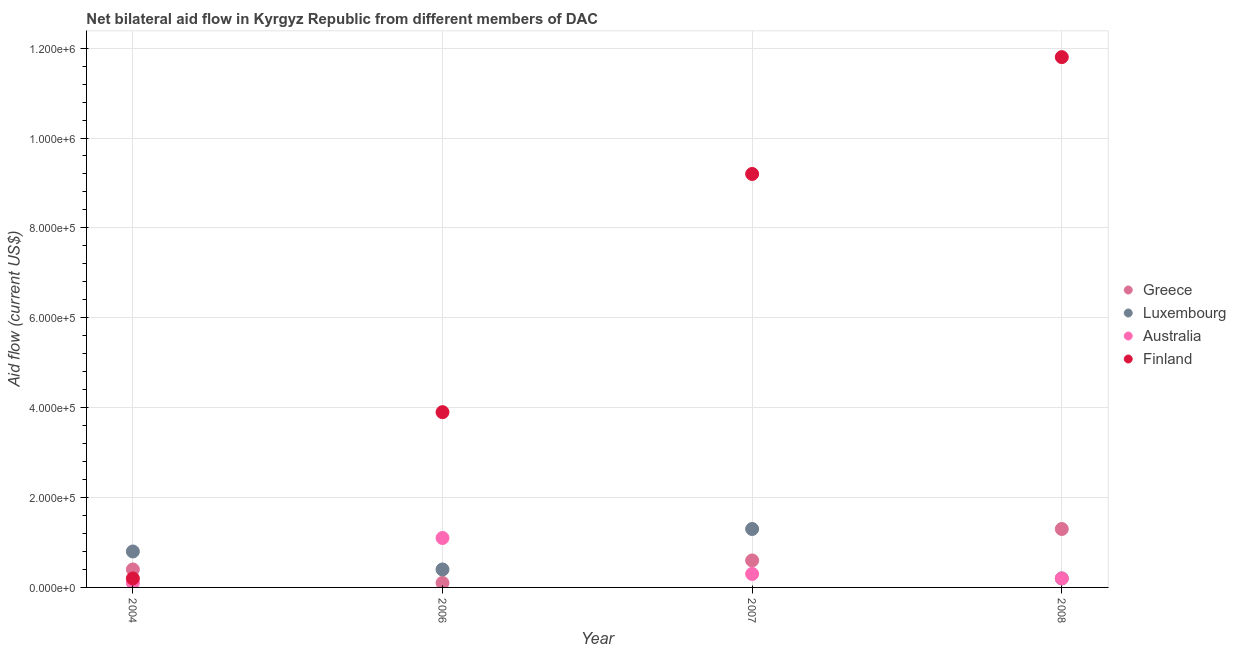What is the amount of aid given by finland in 2007?
Offer a very short reply. 9.20e+05. Across all years, what is the maximum amount of aid given by australia?
Provide a short and direct response. 1.10e+05. Across all years, what is the minimum amount of aid given by greece?
Your response must be concise. 10000. What is the total amount of aid given by greece in the graph?
Provide a short and direct response. 2.40e+05. What is the difference between the amount of aid given by luxembourg in 2004 and that in 2008?
Offer a very short reply. 6.00e+04. What is the difference between the amount of aid given by greece in 2007 and the amount of aid given by australia in 2006?
Your answer should be compact. -5.00e+04. In the year 2007, what is the difference between the amount of aid given by australia and amount of aid given by greece?
Offer a very short reply. -3.00e+04. What is the ratio of the amount of aid given by greece in 2006 to that in 2008?
Offer a very short reply. 0.08. Is the amount of aid given by australia in 2004 less than that in 2006?
Offer a terse response. Yes. Is the difference between the amount of aid given by australia in 2006 and 2007 greater than the difference between the amount of aid given by greece in 2006 and 2007?
Your answer should be compact. Yes. What is the difference between the highest and the second highest amount of aid given by luxembourg?
Keep it short and to the point. 5.00e+04. What is the difference between the highest and the lowest amount of aid given by luxembourg?
Provide a succinct answer. 1.10e+05. Is the sum of the amount of aid given by australia in 2004 and 2007 greater than the maximum amount of aid given by finland across all years?
Provide a succinct answer. No. Is the amount of aid given by australia strictly greater than the amount of aid given by greece over the years?
Provide a short and direct response. No. Is the amount of aid given by greece strictly less than the amount of aid given by finland over the years?
Offer a very short reply. No. Are the values on the major ticks of Y-axis written in scientific E-notation?
Provide a succinct answer. Yes. Where does the legend appear in the graph?
Provide a succinct answer. Center right. What is the title of the graph?
Ensure brevity in your answer.  Net bilateral aid flow in Kyrgyz Republic from different members of DAC. Does "Quality of logistic services" appear as one of the legend labels in the graph?
Offer a terse response. No. What is the label or title of the Y-axis?
Your answer should be compact. Aid flow (current US$). What is the Aid flow (current US$) of Greece in 2004?
Ensure brevity in your answer.  4.00e+04. What is the Aid flow (current US$) of Australia in 2006?
Make the answer very short. 1.10e+05. What is the Aid flow (current US$) in Luxembourg in 2007?
Your answer should be compact. 1.30e+05. What is the Aid flow (current US$) of Finland in 2007?
Provide a succinct answer. 9.20e+05. What is the Aid flow (current US$) in Australia in 2008?
Ensure brevity in your answer.  2.00e+04. What is the Aid flow (current US$) of Finland in 2008?
Ensure brevity in your answer.  1.18e+06. Across all years, what is the maximum Aid flow (current US$) in Luxembourg?
Make the answer very short. 1.30e+05. Across all years, what is the maximum Aid flow (current US$) of Australia?
Make the answer very short. 1.10e+05. Across all years, what is the maximum Aid flow (current US$) in Finland?
Give a very brief answer. 1.18e+06. Across all years, what is the minimum Aid flow (current US$) in Luxembourg?
Give a very brief answer. 2.00e+04. Across all years, what is the minimum Aid flow (current US$) in Australia?
Your response must be concise. 10000. What is the total Aid flow (current US$) in Greece in the graph?
Your answer should be compact. 2.40e+05. What is the total Aid flow (current US$) of Australia in the graph?
Offer a very short reply. 1.70e+05. What is the total Aid flow (current US$) in Finland in the graph?
Your answer should be compact. 2.51e+06. What is the difference between the Aid flow (current US$) of Australia in 2004 and that in 2006?
Your response must be concise. -1.00e+05. What is the difference between the Aid flow (current US$) of Finland in 2004 and that in 2006?
Provide a short and direct response. -3.70e+05. What is the difference between the Aid flow (current US$) in Luxembourg in 2004 and that in 2007?
Your answer should be very brief. -5.00e+04. What is the difference between the Aid flow (current US$) of Finland in 2004 and that in 2007?
Keep it short and to the point. -9.00e+05. What is the difference between the Aid flow (current US$) of Luxembourg in 2004 and that in 2008?
Provide a short and direct response. 6.00e+04. What is the difference between the Aid flow (current US$) of Finland in 2004 and that in 2008?
Ensure brevity in your answer.  -1.16e+06. What is the difference between the Aid flow (current US$) in Luxembourg in 2006 and that in 2007?
Your response must be concise. -9.00e+04. What is the difference between the Aid flow (current US$) in Australia in 2006 and that in 2007?
Your answer should be compact. 8.00e+04. What is the difference between the Aid flow (current US$) of Finland in 2006 and that in 2007?
Ensure brevity in your answer.  -5.30e+05. What is the difference between the Aid flow (current US$) in Luxembourg in 2006 and that in 2008?
Your response must be concise. 2.00e+04. What is the difference between the Aid flow (current US$) of Australia in 2006 and that in 2008?
Your response must be concise. 9.00e+04. What is the difference between the Aid flow (current US$) in Finland in 2006 and that in 2008?
Your answer should be very brief. -7.90e+05. What is the difference between the Aid flow (current US$) in Greece in 2007 and that in 2008?
Provide a succinct answer. -7.00e+04. What is the difference between the Aid flow (current US$) of Greece in 2004 and the Aid flow (current US$) of Finland in 2006?
Provide a short and direct response. -3.50e+05. What is the difference between the Aid flow (current US$) of Luxembourg in 2004 and the Aid flow (current US$) of Australia in 2006?
Keep it short and to the point. -3.00e+04. What is the difference between the Aid flow (current US$) of Luxembourg in 2004 and the Aid flow (current US$) of Finland in 2006?
Make the answer very short. -3.10e+05. What is the difference between the Aid flow (current US$) in Australia in 2004 and the Aid flow (current US$) in Finland in 2006?
Offer a terse response. -3.80e+05. What is the difference between the Aid flow (current US$) in Greece in 2004 and the Aid flow (current US$) in Finland in 2007?
Your answer should be compact. -8.80e+05. What is the difference between the Aid flow (current US$) of Luxembourg in 2004 and the Aid flow (current US$) of Finland in 2007?
Provide a succinct answer. -8.40e+05. What is the difference between the Aid flow (current US$) of Australia in 2004 and the Aid flow (current US$) of Finland in 2007?
Ensure brevity in your answer.  -9.10e+05. What is the difference between the Aid flow (current US$) of Greece in 2004 and the Aid flow (current US$) of Luxembourg in 2008?
Offer a terse response. 2.00e+04. What is the difference between the Aid flow (current US$) in Greece in 2004 and the Aid flow (current US$) in Finland in 2008?
Give a very brief answer. -1.14e+06. What is the difference between the Aid flow (current US$) in Luxembourg in 2004 and the Aid flow (current US$) in Finland in 2008?
Your answer should be compact. -1.10e+06. What is the difference between the Aid flow (current US$) in Australia in 2004 and the Aid flow (current US$) in Finland in 2008?
Provide a short and direct response. -1.17e+06. What is the difference between the Aid flow (current US$) in Greece in 2006 and the Aid flow (current US$) in Luxembourg in 2007?
Ensure brevity in your answer.  -1.20e+05. What is the difference between the Aid flow (current US$) in Greece in 2006 and the Aid flow (current US$) in Australia in 2007?
Your answer should be compact. -2.00e+04. What is the difference between the Aid flow (current US$) in Greece in 2006 and the Aid flow (current US$) in Finland in 2007?
Give a very brief answer. -9.10e+05. What is the difference between the Aid flow (current US$) of Luxembourg in 2006 and the Aid flow (current US$) of Australia in 2007?
Provide a succinct answer. 10000. What is the difference between the Aid flow (current US$) in Luxembourg in 2006 and the Aid flow (current US$) in Finland in 2007?
Your response must be concise. -8.80e+05. What is the difference between the Aid flow (current US$) of Australia in 2006 and the Aid flow (current US$) of Finland in 2007?
Provide a short and direct response. -8.10e+05. What is the difference between the Aid flow (current US$) of Greece in 2006 and the Aid flow (current US$) of Finland in 2008?
Offer a terse response. -1.17e+06. What is the difference between the Aid flow (current US$) of Luxembourg in 2006 and the Aid flow (current US$) of Finland in 2008?
Your response must be concise. -1.14e+06. What is the difference between the Aid flow (current US$) of Australia in 2006 and the Aid flow (current US$) of Finland in 2008?
Your answer should be very brief. -1.07e+06. What is the difference between the Aid flow (current US$) of Greece in 2007 and the Aid flow (current US$) of Finland in 2008?
Provide a succinct answer. -1.12e+06. What is the difference between the Aid flow (current US$) in Luxembourg in 2007 and the Aid flow (current US$) in Australia in 2008?
Make the answer very short. 1.10e+05. What is the difference between the Aid flow (current US$) of Luxembourg in 2007 and the Aid flow (current US$) of Finland in 2008?
Provide a short and direct response. -1.05e+06. What is the difference between the Aid flow (current US$) in Australia in 2007 and the Aid flow (current US$) in Finland in 2008?
Your answer should be compact. -1.15e+06. What is the average Aid flow (current US$) of Greece per year?
Offer a terse response. 6.00e+04. What is the average Aid flow (current US$) of Luxembourg per year?
Provide a short and direct response. 6.75e+04. What is the average Aid flow (current US$) of Australia per year?
Keep it short and to the point. 4.25e+04. What is the average Aid flow (current US$) in Finland per year?
Your answer should be very brief. 6.28e+05. In the year 2004, what is the difference between the Aid flow (current US$) in Luxembourg and Aid flow (current US$) in Australia?
Offer a very short reply. 7.00e+04. In the year 2006, what is the difference between the Aid flow (current US$) in Greece and Aid flow (current US$) in Luxembourg?
Give a very brief answer. -3.00e+04. In the year 2006, what is the difference between the Aid flow (current US$) in Greece and Aid flow (current US$) in Australia?
Your answer should be very brief. -1.00e+05. In the year 2006, what is the difference between the Aid flow (current US$) in Greece and Aid flow (current US$) in Finland?
Your response must be concise. -3.80e+05. In the year 2006, what is the difference between the Aid flow (current US$) of Luxembourg and Aid flow (current US$) of Finland?
Give a very brief answer. -3.50e+05. In the year 2006, what is the difference between the Aid flow (current US$) in Australia and Aid flow (current US$) in Finland?
Give a very brief answer. -2.80e+05. In the year 2007, what is the difference between the Aid flow (current US$) of Greece and Aid flow (current US$) of Finland?
Your response must be concise. -8.60e+05. In the year 2007, what is the difference between the Aid flow (current US$) in Luxembourg and Aid flow (current US$) in Finland?
Ensure brevity in your answer.  -7.90e+05. In the year 2007, what is the difference between the Aid flow (current US$) in Australia and Aid flow (current US$) in Finland?
Your response must be concise. -8.90e+05. In the year 2008, what is the difference between the Aid flow (current US$) in Greece and Aid flow (current US$) in Luxembourg?
Your response must be concise. 1.10e+05. In the year 2008, what is the difference between the Aid flow (current US$) of Greece and Aid flow (current US$) of Australia?
Offer a terse response. 1.10e+05. In the year 2008, what is the difference between the Aid flow (current US$) in Greece and Aid flow (current US$) in Finland?
Offer a very short reply. -1.05e+06. In the year 2008, what is the difference between the Aid flow (current US$) of Luxembourg and Aid flow (current US$) of Australia?
Keep it short and to the point. 0. In the year 2008, what is the difference between the Aid flow (current US$) of Luxembourg and Aid flow (current US$) of Finland?
Your answer should be compact. -1.16e+06. In the year 2008, what is the difference between the Aid flow (current US$) of Australia and Aid flow (current US$) of Finland?
Your response must be concise. -1.16e+06. What is the ratio of the Aid flow (current US$) in Greece in 2004 to that in 2006?
Provide a succinct answer. 4. What is the ratio of the Aid flow (current US$) in Luxembourg in 2004 to that in 2006?
Ensure brevity in your answer.  2. What is the ratio of the Aid flow (current US$) in Australia in 2004 to that in 2006?
Keep it short and to the point. 0.09. What is the ratio of the Aid flow (current US$) in Finland in 2004 to that in 2006?
Ensure brevity in your answer.  0.05. What is the ratio of the Aid flow (current US$) in Greece in 2004 to that in 2007?
Your answer should be compact. 0.67. What is the ratio of the Aid flow (current US$) of Luxembourg in 2004 to that in 2007?
Your response must be concise. 0.62. What is the ratio of the Aid flow (current US$) of Finland in 2004 to that in 2007?
Offer a terse response. 0.02. What is the ratio of the Aid flow (current US$) of Greece in 2004 to that in 2008?
Provide a succinct answer. 0.31. What is the ratio of the Aid flow (current US$) in Australia in 2004 to that in 2008?
Ensure brevity in your answer.  0.5. What is the ratio of the Aid flow (current US$) in Finland in 2004 to that in 2008?
Make the answer very short. 0.02. What is the ratio of the Aid flow (current US$) in Luxembourg in 2006 to that in 2007?
Your answer should be compact. 0.31. What is the ratio of the Aid flow (current US$) of Australia in 2006 to that in 2007?
Provide a succinct answer. 3.67. What is the ratio of the Aid flow (current US$) in Finland in 2006 to that in 2007?
Provide a succinct answer. 0.42. What is the ratio of the Aid flow (current US$) of Greece in 2006 to that in 2008?
Make the answer very short. 0.08. What is the ratio of the Aid flow (current US$) in Australia in 2006 to that in 2008?
Provide a short and direct response. 5.5. What is the ratio of the Aid flow (current US$) of Finland in 2006 to that in 2008?
Ensure brevity in your answer.  0.33. What is the ratio of the Aid flow (current US$) in Greece in 2007 to that in 2008?
Provide a short and direct response. 0.46. What is the ratio of the Aid flow (current US$) in Luxembourg in 2007 to that in 2008?
Your answer should be compact. 6.5. What is the ratio of the Aid flow (current US$) of Australia in 2007 to that in 2008?
Provide a succinct answer. 1.5. What is the ratio of the Aid flow (current US$) in Finland in 2007 to that in 2008?
Ensure brevity in your answer.  0.78. What is the difference between the highest and the second highest Aid flow (current US$) of Greece?
Provide a short and direct response. 7.00e+04. What is the difference between the highest and the second highest Aid flow (current US$) in Luxembourg?
Keep it short and to the point. 5.00e+04. What is the difference between the highest and the second highest Aid flow (current US$) of Australia?
Make the answer very short. 8.00e+04. What is the difference between the highest and the lowest Aid flow (current US$) of Greece?
Give a very brief answer. 1.20e+05. What is the difference between the highest and the lowest Aid flow (current US$) of Luxembourg?
Ensure brevity in your answer.  1.10e+05. What is the difference between the highest and the lowest Aid flow (current US$) of Finland?
Keep it short and to the point. 1.16e+06. 